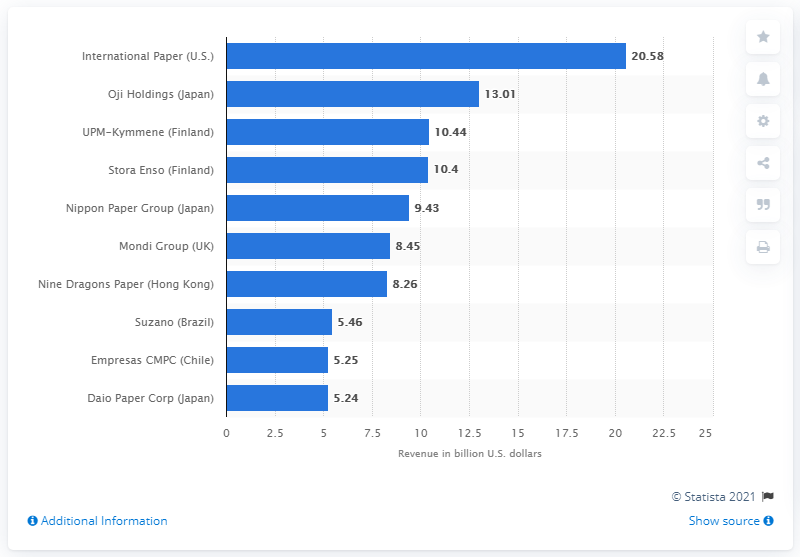Point out several critical features in this image. Oji Holdings reported revenue of 13.01 billion USD in the United States in 2020. 